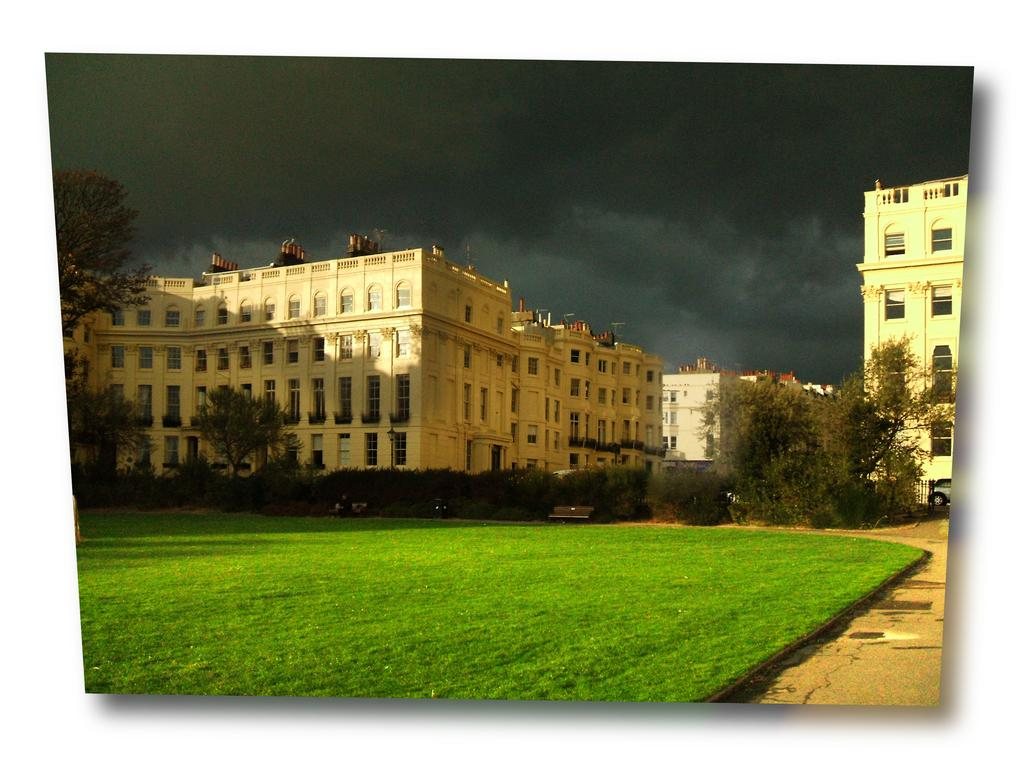What type of vegetation is present in the image? There is grass in the image. What else can be seen in the image besides grass? There are trees, buildings, clouds, and the sky visible in the image. Can you describe the architectural features in the image? There are buildings and windows present in the image. What is a piece of furniture that can be seen in the image? There is a bench in the image. What type of nut is being used to secure the cable in the image? There is no nut or cable present in the image. What command is given to the people in the image to stop their activity? There are no people or activity present in the image. 